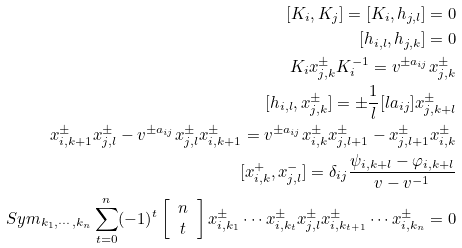Convert formula to latex. <formula><loc_0><loc_0><loc_500><loc_500>[ K _ { i } , K _ { j } ] = [ K _ { i } , h _ { j , l } ] = 0 \\ [ h _ { i , l } , h _ { j , k } ] = 0 \\ K _ { i } x ^ { \pm } _ { j , k } K ^ { - 1 } _ { i } = v ^ { \pm a _ { i j } } x ^ { \pm } _ { j , k } \\ [ h _ { i , l } , x ^ { \pm } _ { j , k } ] = \pm \frac { 1 } { l } [ l a _ { i j } ] x ^ { \pm } _ { j , k + l } \\ x ^ { \pm } _ { i , k + 1 } x ^ { \pm } _ { j , l } - v ^ { \pm a _ { i j } } x ^ { \pm } _ { j , l } x ^ { \pm } _ { i , k + 1 } = v ^ { \pm a _ { i j } } x ^ { \pm } _ { i , k } x ^ { \pm } _ { j , l + 1 } - x ^ { \pm } _ { j , l + 1 } x ^ { \pm } _ { i , k } \\ [ x ^ { + } _ { i , k } , x ^ { - } _ { j , l } ] = \delta _ { i j } \frac { \psi _ { i , k + l } - \varphi _ { i , k + l } } { v - v ^ { - 1 } } \\ S y m _ { k _ { 1 } , \cdots , k _ { n } } \sum ^ { n } _ { t = 0 } ( - 1 ) ^ { t } \left [ \begin{array} { c } n \\ t \\ \end{array} \right ] x ^ { \pm } _ { i , k _ { 1 } } \cdots x ^ { \pm } _ { i , k _ { t } } x ^ { \pm } _ { j , l } x ^ { \pm } _ { i , k _ { t + 1 } } \cdots x ^ { \pm } _ { i , k _ { n } } = 0</formula> 